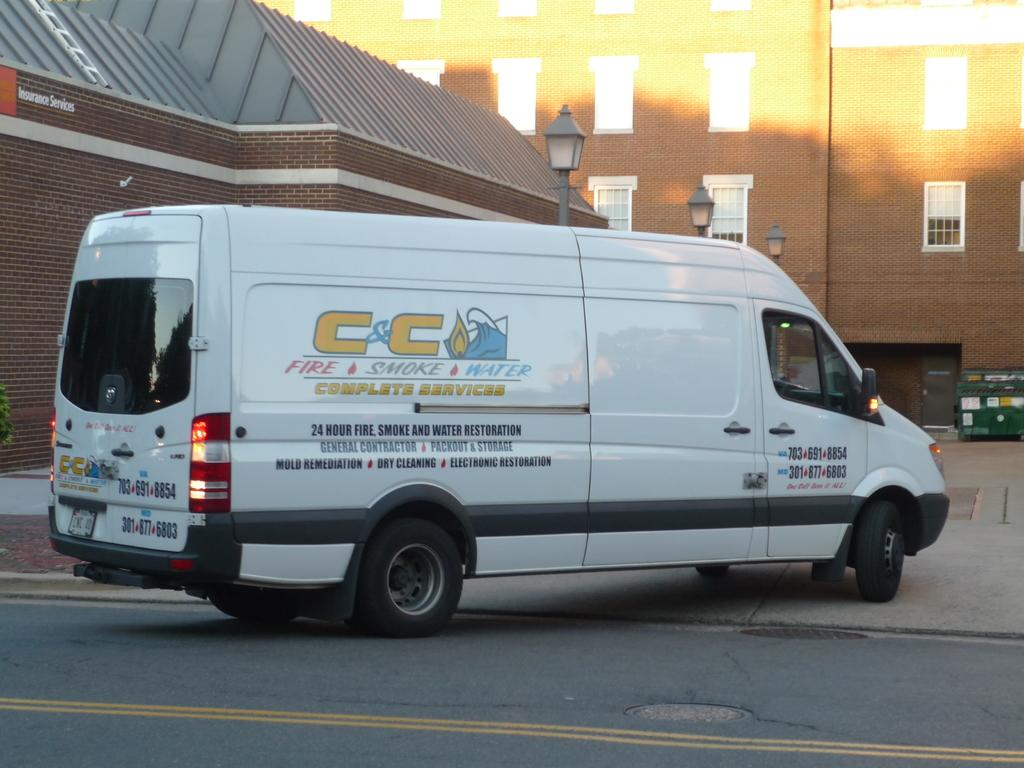<image>
Create a compact narrative representing the image presented. A white cargo van with a C&C logo on it. 